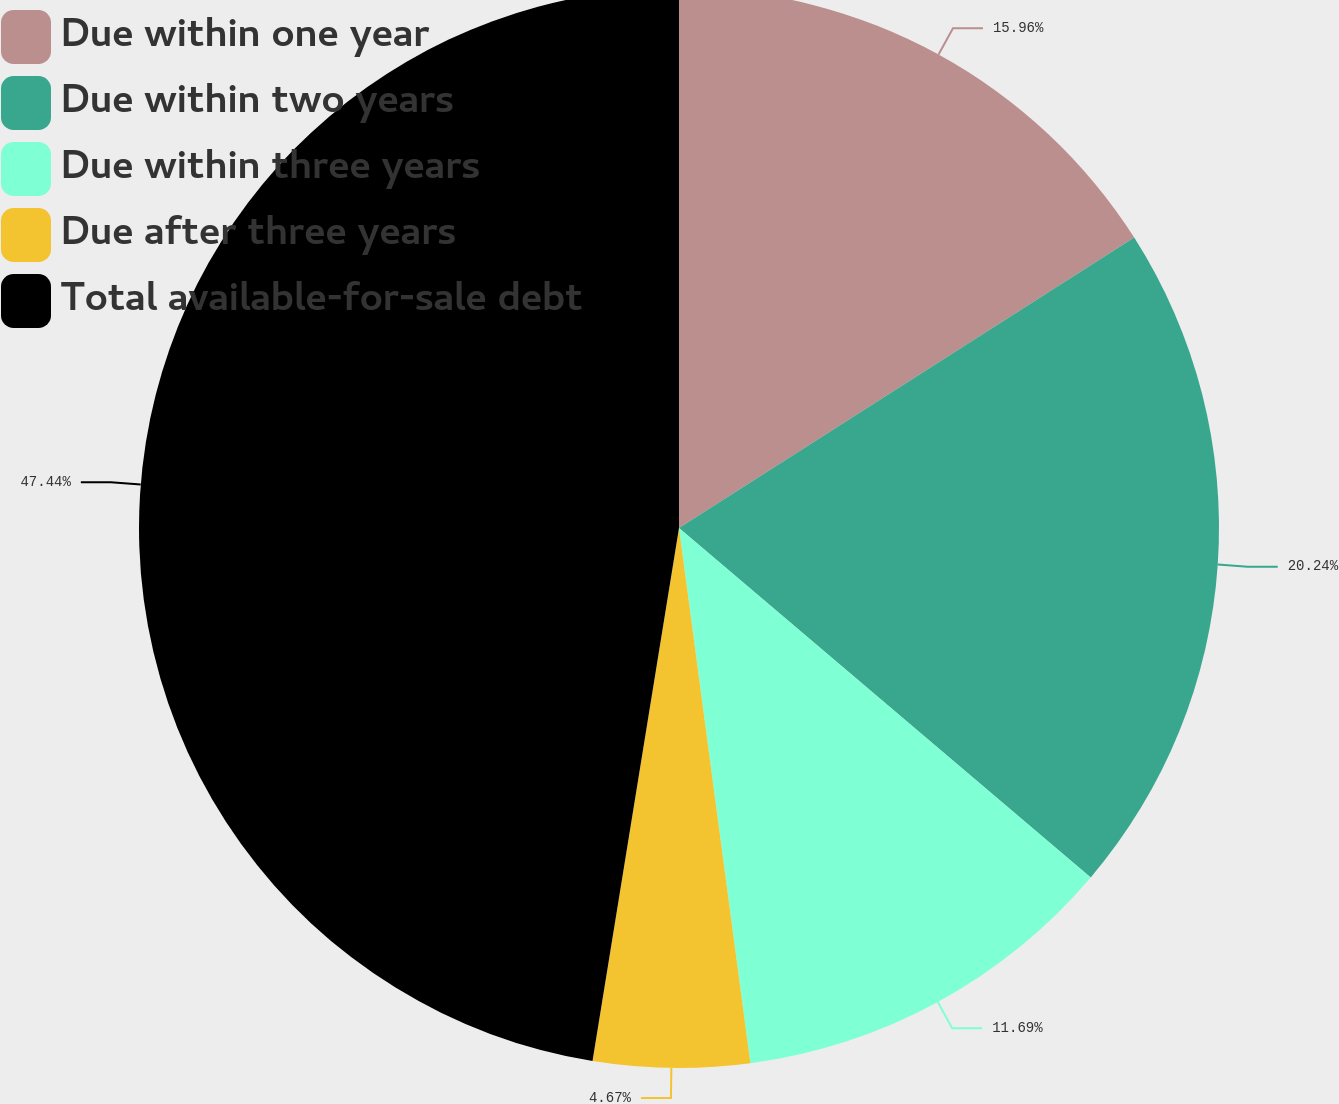Convert chart. <chart><loc_0><loc_0><loc_500><loc_500><pie_chart><fcel>Due within one year<fcel>Due within two years<fcel>Due within three years<fcel>Due after three years<fcel>Total available-for-sale debt<nl><fcel>15.96%<fcel>20.24%<fcel>11.69%<fcel>4.67%<fcel>47.44%<nl></chart> 